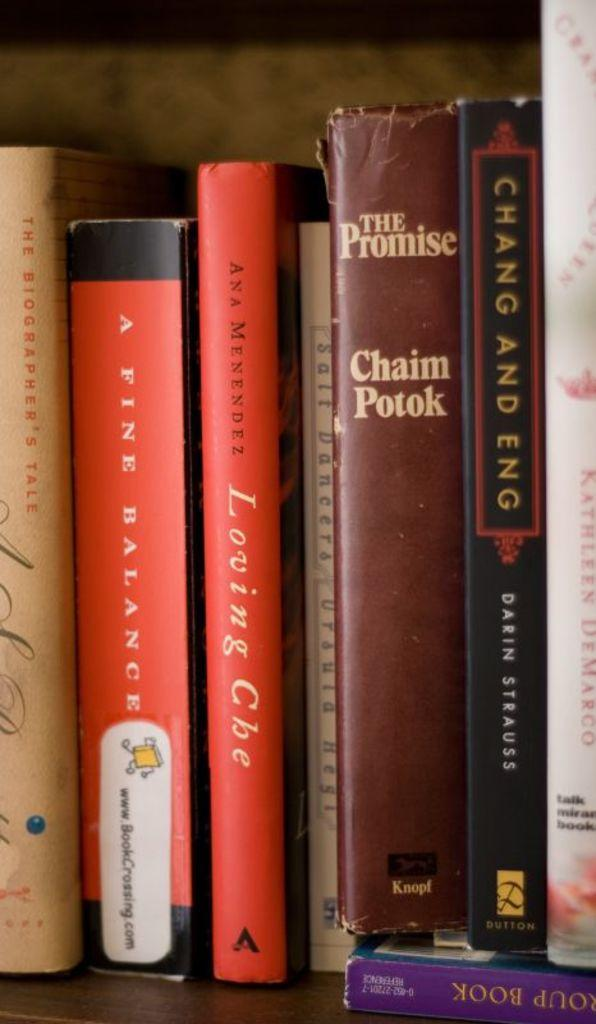<image>
Provide a brief description of the given image. several books on a shelf including a fine balance, the promise, and chang and eng 